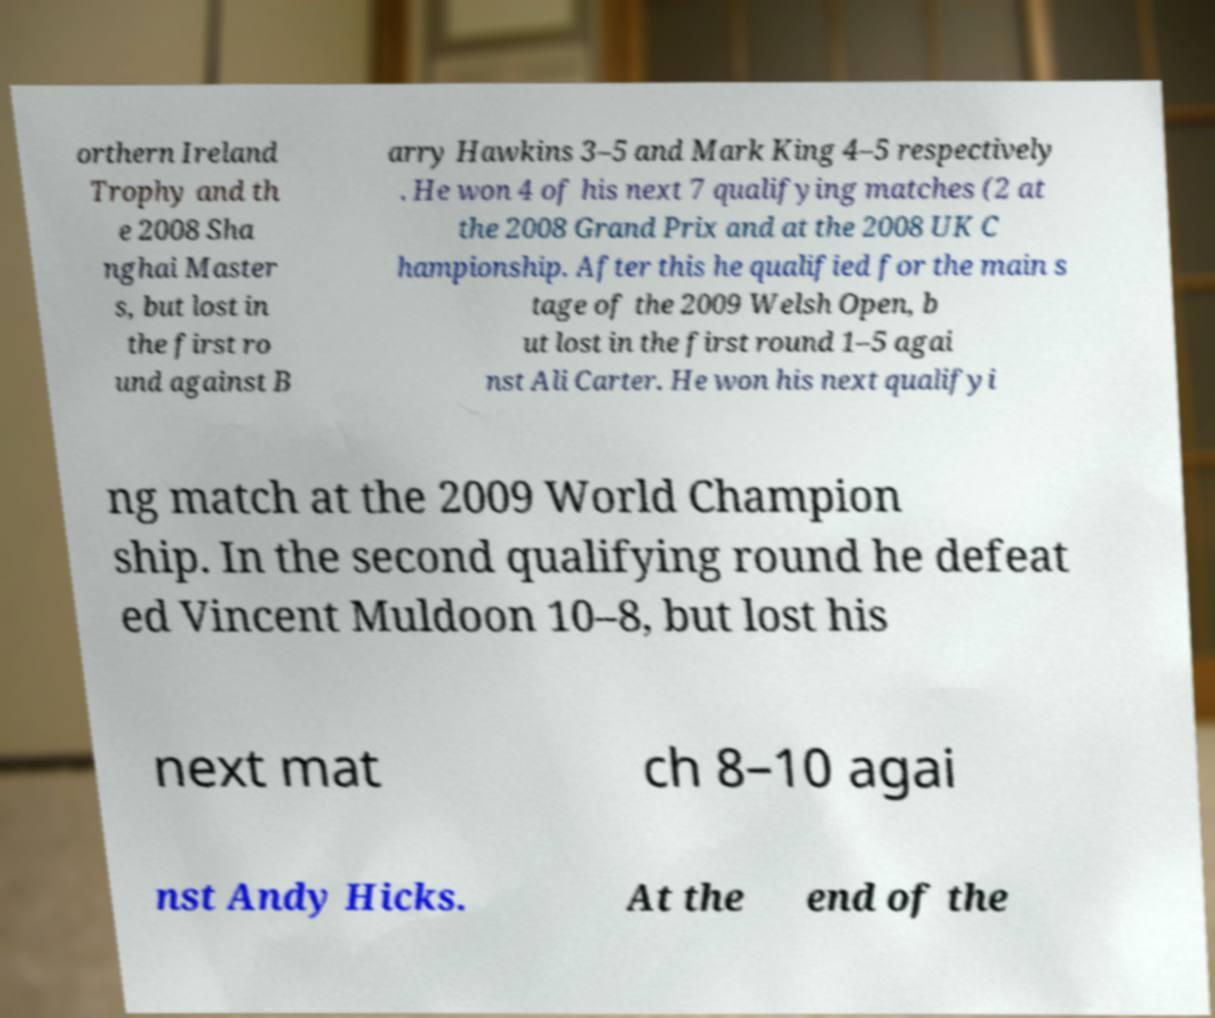Please read and relay the text visible in this image. What does it say? orthern Ireland Trophy and th e 2008 Sha nghai Master s, but lost in the first ro und against B arry Hawkins 3–5 and Mark King 4–5 respectively . He won 4 of his next 7 qualifying matches (2 at the 2008 Grand Prix and at the 2008 UK C hampionship. After this he qualified for the main s tage of the 2009 Welsh Open, b ut lost in the first round 1–5 agai nst Ali Carter. He won his next qualifyi ng match at the 2009 World Champion ship. In the second qualifying round he defeat ed Vincent Muldoon 10–8, but lost his next mat ch 8–10 agai nst Andy Hicks. At the end of the 